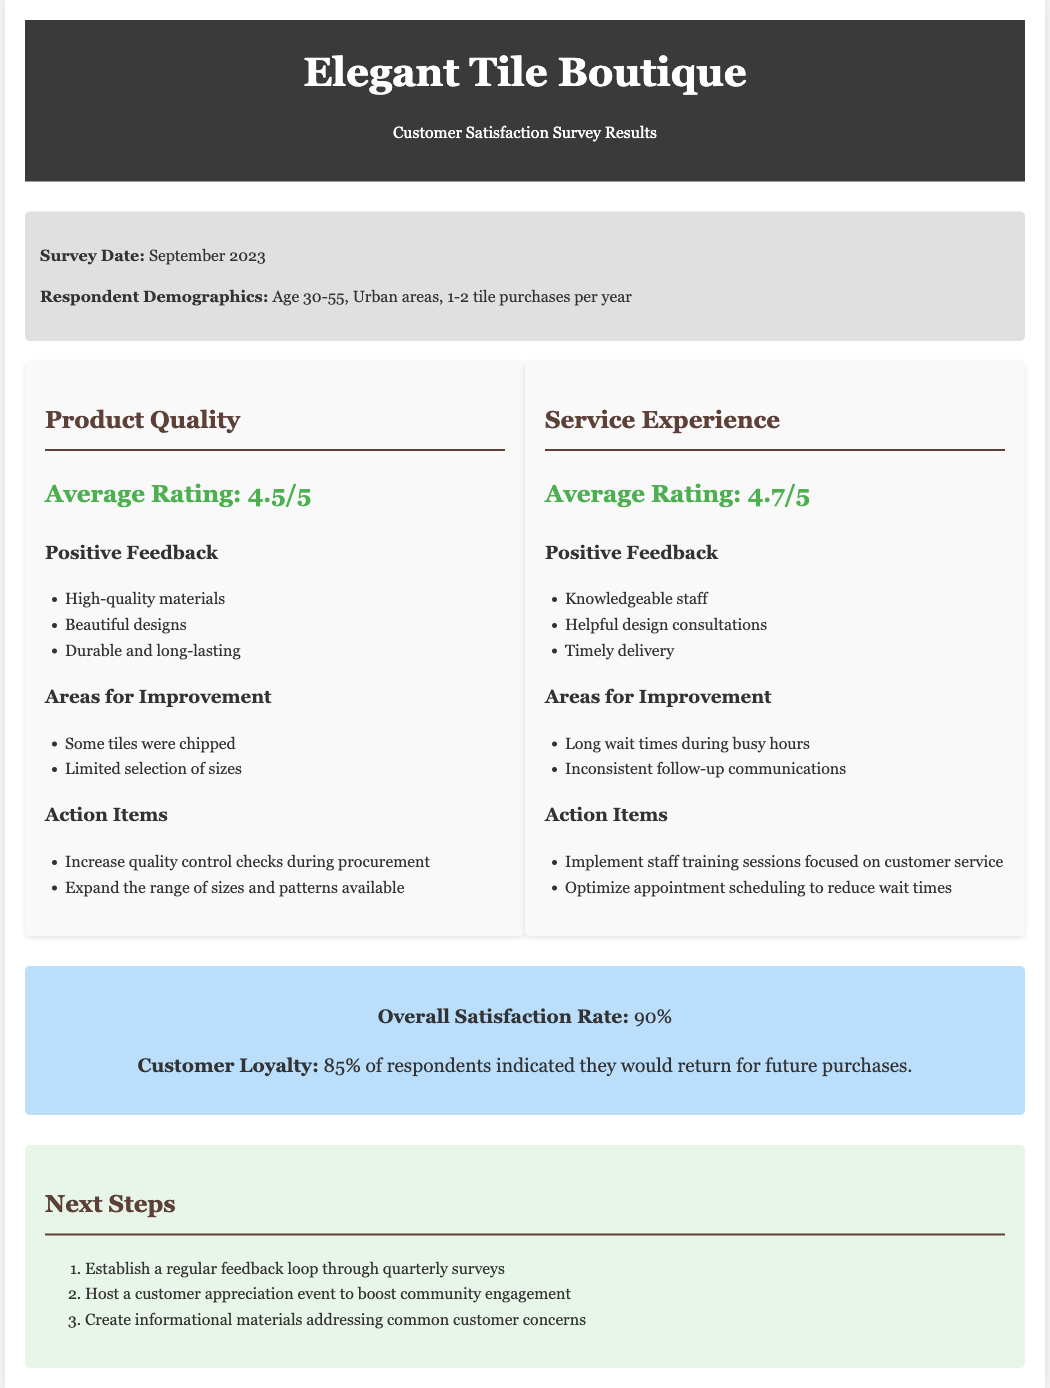What was the average rating for product quality? The average rating for product quality was explicitly mentioned in the document.
Answer: 4.5/5 What percentage of respondents indicated they would return for future purchases? The document states the percentage of respondents regarding future purchases.
Answer: 85% What are the two areas for improvement in the service experience? The document lists specific areas for improvement in the service experience.
Answer: Long wait times during busy hours, Inconsistent follow-up communications What is one positive feedback about the product quality? Positive feedback on product quality is provided in a list in the document.
Answer: High-quality materials What is the overall satisfaction rate? The overall satisfaction rate is given clearly in the document.
Answer: 90% What action item is suggested for product quality? Action items for product quality are available in the document.
Answer: Increase quality control checks during procurement What is the survey date mentioned in the document? The survey date is specified in the document as part of the survey information.
Answer: September 2023 What kind of event is suggested in the next steps? The document details the next steps, including a specific type of event.
Answer: Customer appreciation event What average rating was provided for service experience? The document lists the average rating for service experience explicitly.
Answer: 4.7/5 